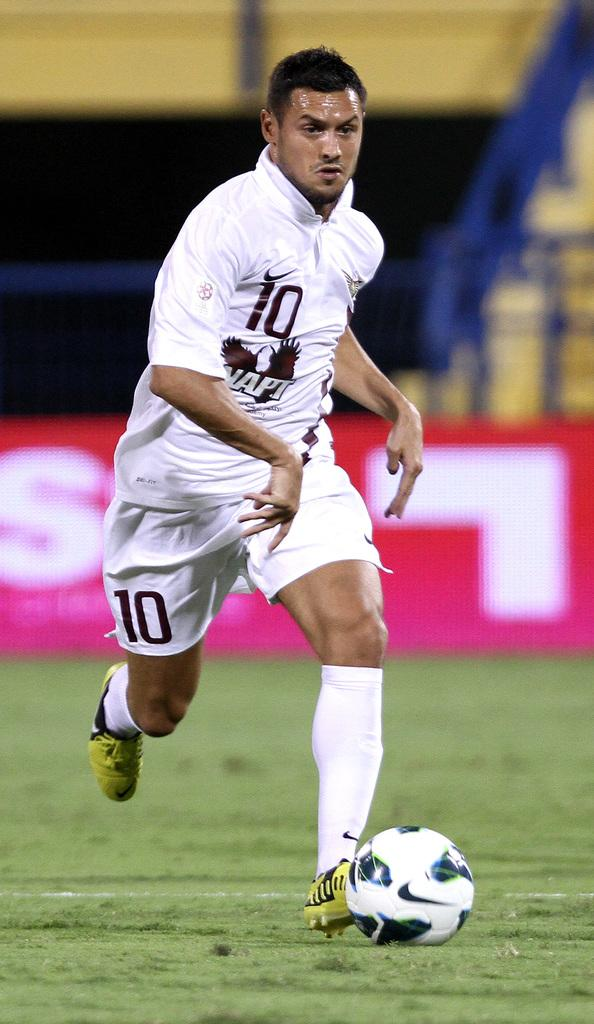<image>
Offer a succinct explanation of the picture presented. The number 10 soccer player is running with the ball on a pitch. 